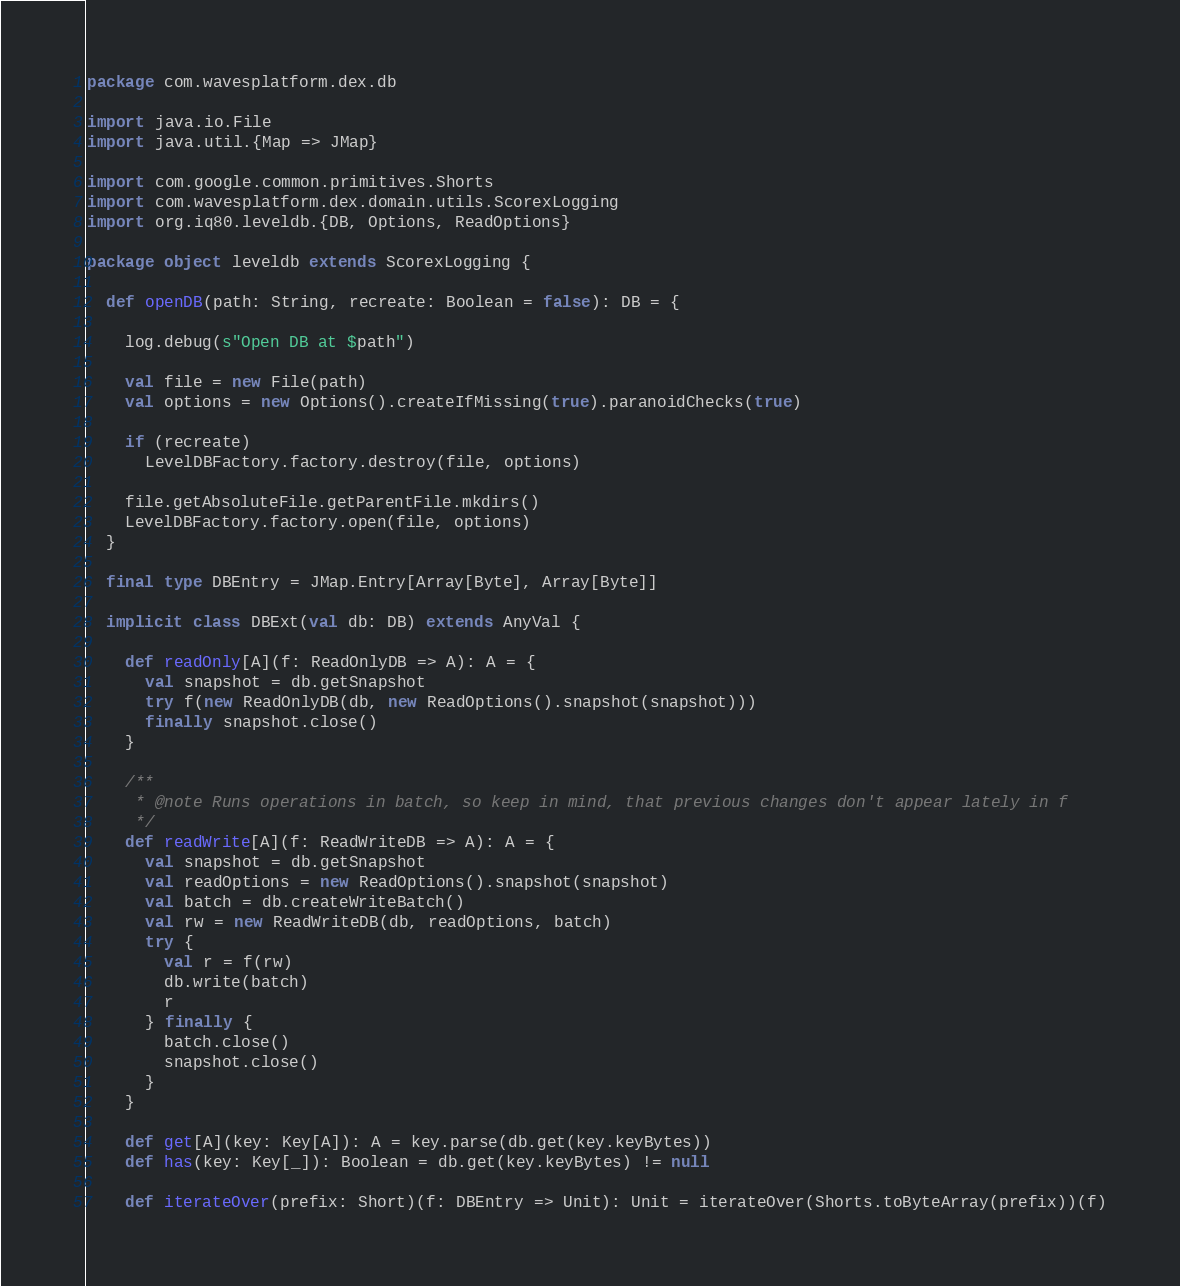<code> <loc_0><loc_0><loc_500><loc_500><_Scala_>package com.wavesplatform.dex.db

import java.io.File
import java.util.{Map => JMap}

import com.google.common.primitives.Shorts
import com.wavesplatform.dex.domain.utils.ScorexLogging
import org.iq80.leveldb.{DB, Options, ReadOptions}

package object leveldb extends ScorexLogging {

  def openDB(path: String, recreate: Boolean = false): DB = {

    log.debug(s"Open DB at $path")

    val file = new File(path)
    val options = new Options().createIfMissing(true).paranoidChecks(true)

    if (recreate)
      LevelDBFactory.factory.destroy(file, options)

    file.getAbsoluteFile.getParentFile.mkdirs()
    LevelDBFactory.factory.open(file, options)
  }

  final type DBEntry = JMap.Entry[Array[Byte], Array[Byte]]

  implicit class DBExt(val db: DB) extends AnyVal {

    def readOnly[A](f: ReadOnlyDB => A): A = {
      val snapshot = db.getSnapshot
      try f(new ReadOnlyDB(db, new ReadOptions().snapshot(snapshot)))
      finally snapshot.close()
    }

    /**
     * @note Runs operations in batch, so keep in mind, that previous changes don't appear lately in f
     */
    def readWrite[A](f: ReadWriteDB => A): A = {
      val snapshot = db.getSnapshot
      val readOptions = new ReadOptions().snapshot(snapshot)
      val batch = db.createWriteBatch()
      val rw = new ReadWriteDB(db, readOptions, batch)
      try {
        val r = f(rw)
        db.write(batch)
        r
      } finally {
        batch.close()
        snapshot.close()
      }
    }

    def get[A](key: Key[A]): A = key.parse(db.get(key.keyBytes))
    def has(key: Key[_]): Boolean = db.get(key.keyBytes) != null

    def iterateOver(prefix: Short)(f: DBEntry => Unit): Unit = iterateOver(Shorts.toByteArray(prefix))(f)
</code> 